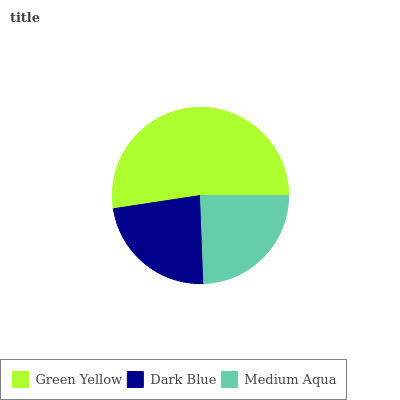Is Dark Blue the minimum?
Answer yes or no. Yes. Is Green Yellow the maximum?
Answer yes or no. Yes. Is Medium Aqua the minimum?
Answer yes or no. No. Is Medium Aqua the maximum?
Answer yes or no. No. Is Medium Aqua greater than Dark Blue?
Answer yes or no. Yes. Is Dark Blue less than Medium Aqua?
Answer yes or no. Yes. Is Dark Blue greater than Medium Aqua?
Answer yes or no. No. Is Medium Aqua less than Dark Blue?
Answer yes or no. No. Is Medium Aqua the high median?
Answer yes or no. Yes. Is Medium Aqua the low median?
Answer yes or no. Yes. Is Dark Blue the high median?
Answer yes or no. No. Is Green Yellow the low median?
Answer yes or no. No. 